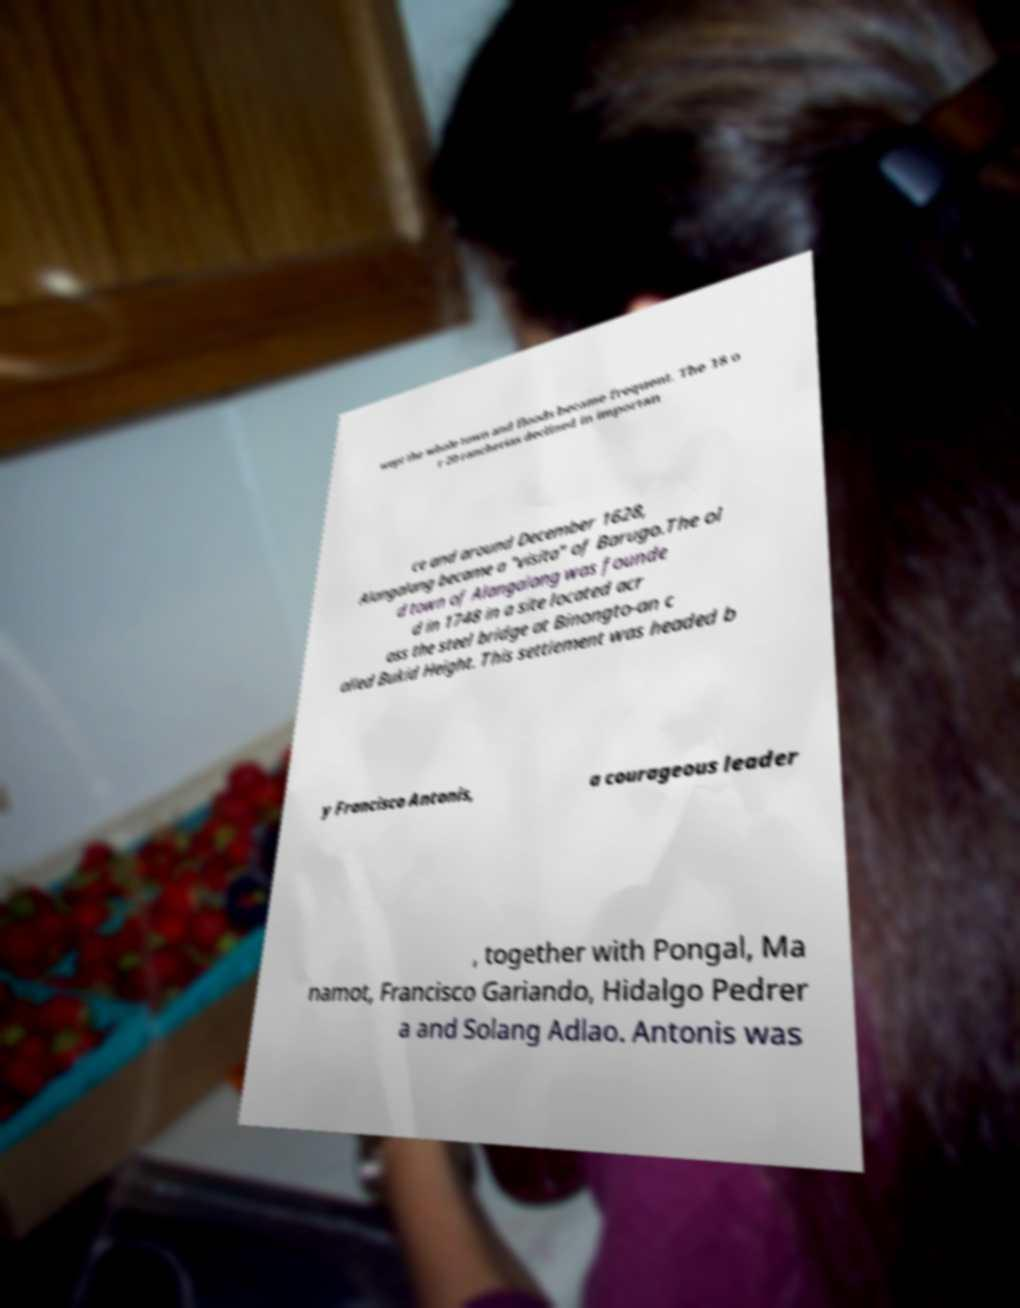Please read and relay the text visible in this image. What does it say? wept the whole town and floods became frequent. The 18 o r 20 rancherias declined in importan ce and around December 1628, Alangalang became a "visita" of Barugo.The ol d town of Alangalang was founde d in 1748 in a site located acr oss the steel bridge at Binongto-an c alled Bukid Height. This settlement was headed b y Francisco Antonis, a courageous leader , together with Pongal, Ma namot, Francisco Gariando, Hidalgo Pedrer a and Solang Adlao. Antonis was 